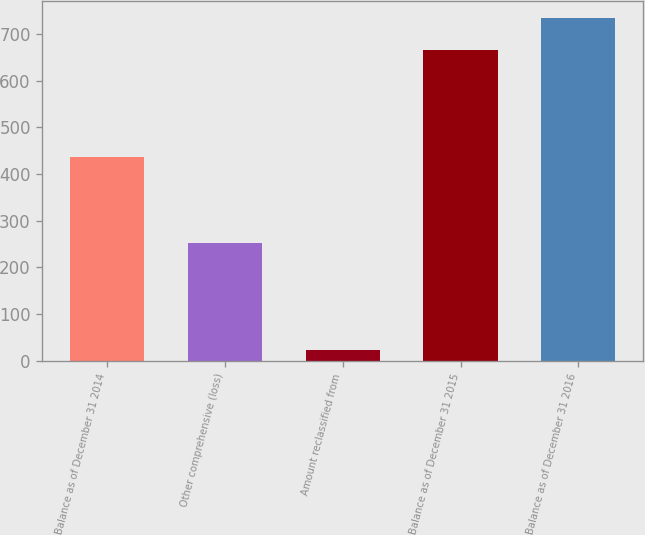Convert chart to OTSL. <chart><loc_0><loc_0><loc_500><loc_500><bar_chart><fcel>Balance as of December 31 2014<fcel>Other comprehensive (loss)<fcel>Amount reclassified from<fcel>Balance as of December 31 2015<fcel>Balance as of December 31 2016<nl><fcel>436.3<fcel>252.6<fcel>23.3<fcel>665.6<fcel>734.94<nl></chart> 